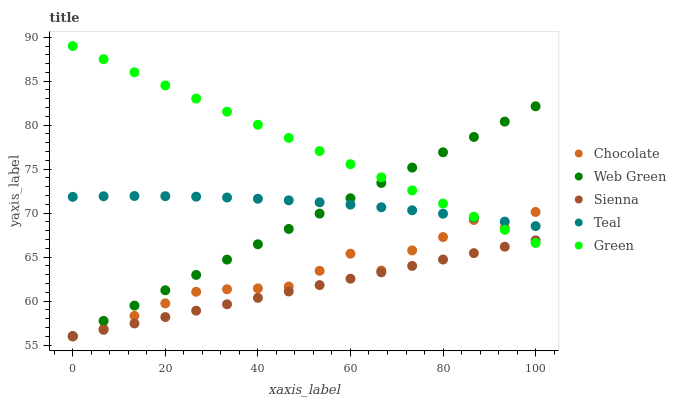Does Sienna have the minimum area under the curve?
Answer yes or no. Yes. Does Green have the maximum area under the curve?
Answer yes or no. Yes. Does Teal have the minimum area under the curve?
Answer yes or no. No. Does Teal have the maximum area under the curve?
Answer yes or no. No. Is Green the smoothest?
Answer yes or no. Yes. Is Chocolate the roughest?
Answer yes or no. Yes. Is Teal the smoothest?
Answer yes or no. No. Is Teal the roughest?
Answer yes or no. No. Does Sienna have the lowest value?
Answer yes or no. Yes. Does Green have the lowest value?
Answer yes or no. No. Does Green have the highest value?
Answer yes or no. Yes. Does Teal have the highest value?
Answer yes or no. No. Is Sienna less than Teal?
Answer yes or no. Yes. Is Teal greater than Sienna?
Answer yes or no. Yes. Does Chocolate intersect Green?
Answer yes or no. Yes. Is Chocolate less than Green?
Answer yes or no. No. Is Chocolate greater than Green?
Answer yes or no. No. Does Sienna intersect Teal?
Answer yes or no. No. 